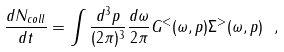<formula> <loc_0><loc_0><loc_500><loc_500>\frac { d N _ { c o l l } } { d t } = \int \frac { d ^ { 3 } p } { ( 2 \pi ) ^ { 3 } } \frac { d \omega } { 2 \pi } G ^ { < } ( \omega , p ) \Sigma ^ { > } ( \omega , p ) \ ,</formula> 